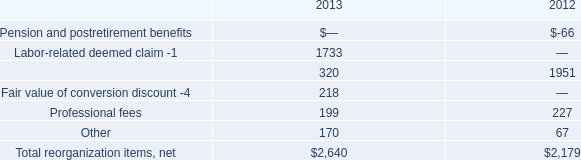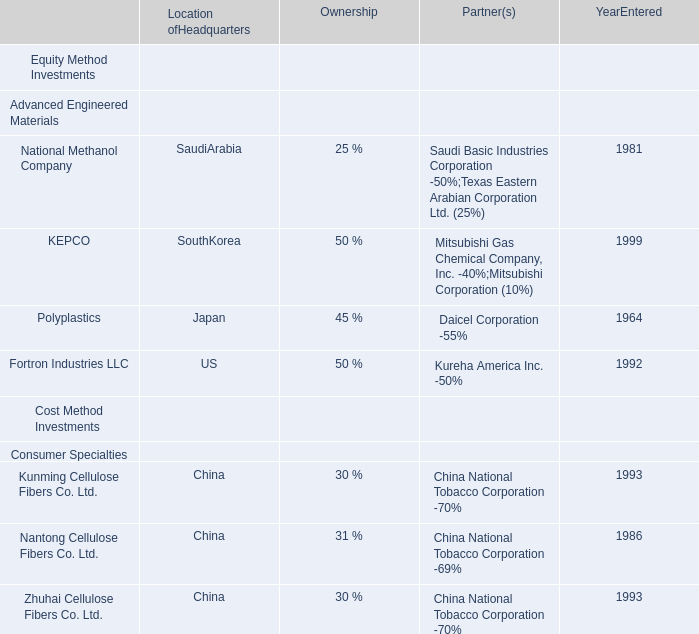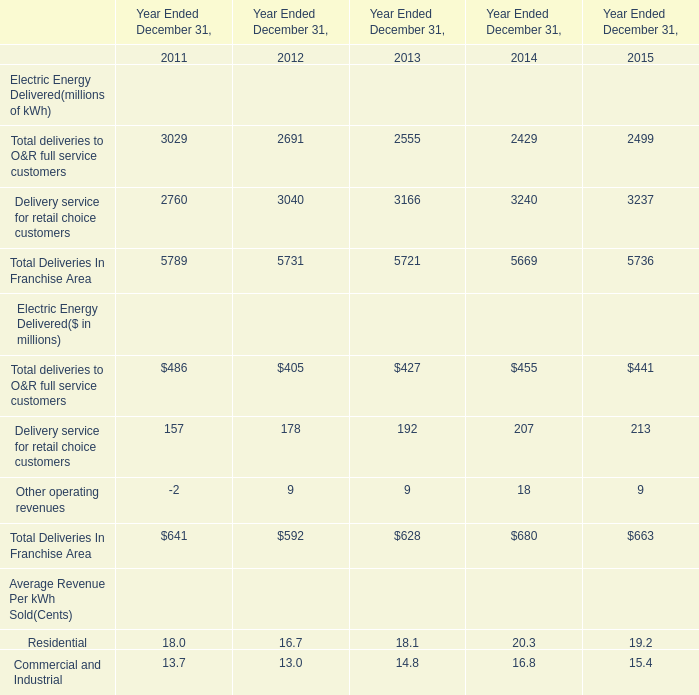what was the percentage growth in the total re-organization costs from 2012 to 2013 
Computations: ((2640 - 2179) / 2179)
Answer: 0.21156. 